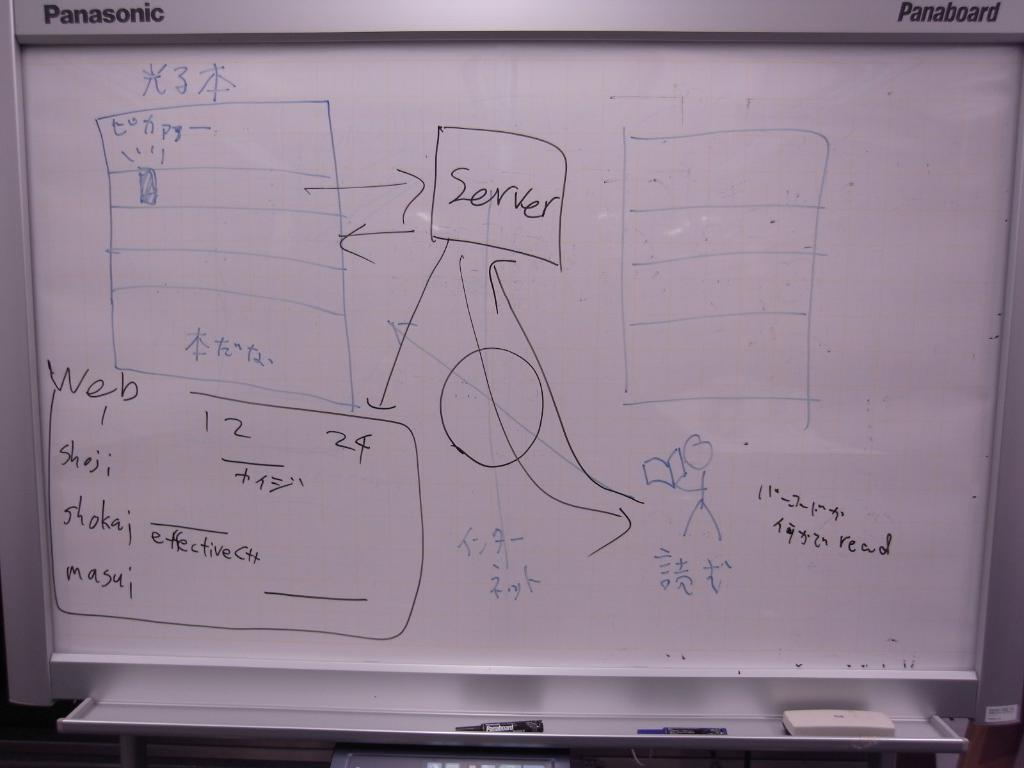Provide a one-sentence caption for the provided image. A dry erase board has the word "server" in a box. 